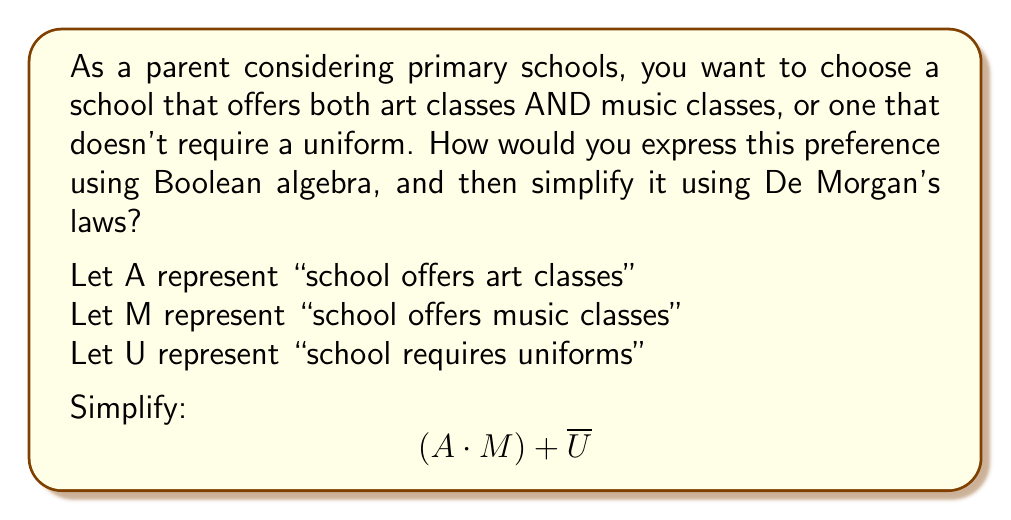Teach me how to tackle this problem. Let's approach this step-by-step:

1) The original expression is: $$(A \cdot M) + \overline{U}$$

2) To apply De Morgan's laws, we need to negate the entire expression:
   $$\overline{((A \cdot M) + \overline{U})}$$

3) Now we can apply De Morgan's first law, which states that the negation of a sum is the product of the negations:
   $$\overline{(A \cdot M)} \cdot \overline{\overline{U}}$$

4) The double negation on U cancels out:
   $$\overline{(A \cdot M)} \cdot U$$

5) We can apply De Morgan's second law to $\overline{(A \cdot M)}$, which states that the negation of a product is the sum of the negations:
   $$(\overline{A} + \overline{M}) \cdot U$$

6) This simplified expression represents schools that either don't offer art classes OR don't offer music classes, AND require uniforms.

7) Since this is the negation of our original preference, we can conclude that our original expression $$(A \cdot M) + \overline{U}$$ cannot be further simplified using De Morgan's laws.
Answer: $$(A \cdot M) + \overline{U}$$ 